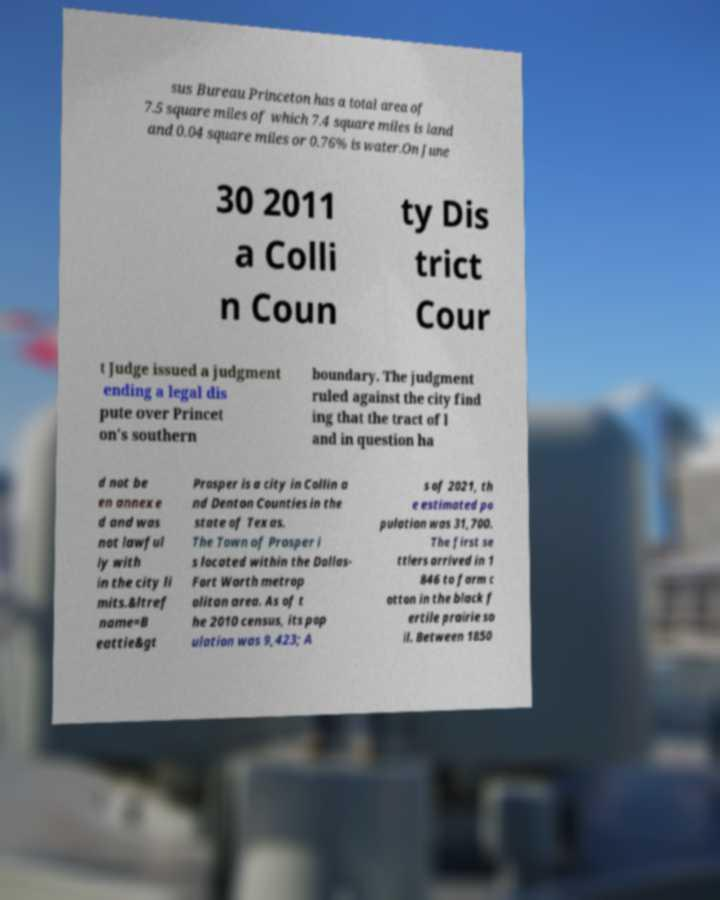There's text embedded in this image that I need extracted. Can you transcribe it verbatim? sus Bureau Princeton has a total area of 7.5 square miles of which 7.4 square miles is land and 0.04 square miles or 0.76% is water.On June 30 2011 a Colli n Coun ty Dis trict Cour t Judge issued a judgment ending a legal dis pute over Princet on's southern boundary. The judgment ruled against the city find ing that the tract of l and in question ha d not be en annexe d and was not lawful ly with in the city li mits.&ltref name=B eattie&gt Prosper is a city in Collin a nd Denton Counties in the state of Texas. The Town of Prosper i s located within the Dallas- Fort Worth metrop olitan area. As of t he 2010 census, its pop ulation was 9,423; A s of 2021, th e estimated po pulation was 31,700. The first se ttlers arrived in 1 846 to farm c otton in the black f ertile prairie so il. Between 1850 